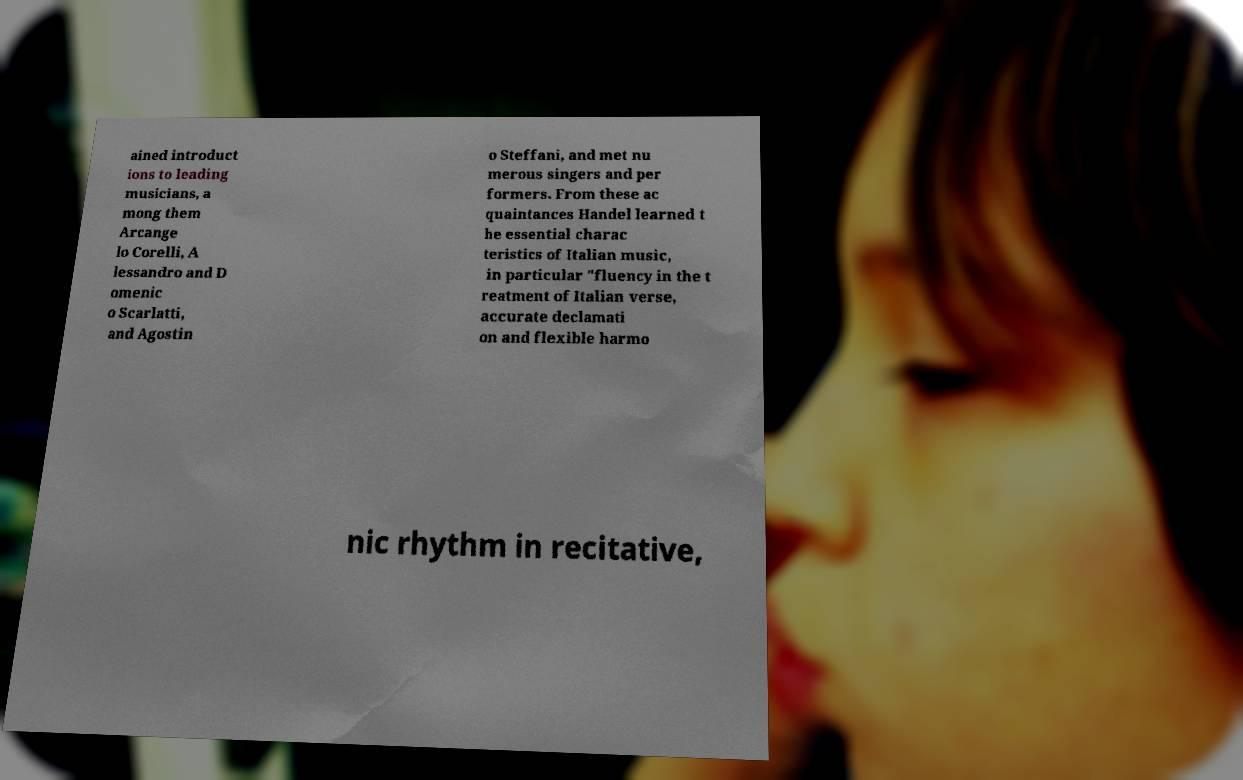There's text embedded in this image that I need extracted. Can you transcribe it verbatim? ained introduct ions to leading musicians, a mong them Arcange lo Corelli, A lessandro and D omenic o Scarlatti, and Agostin o Steffani, and met nu merous singers and per formers. From these ac quaintances Handel learned t he essential charac teristics of Italian music, in particular "fluency in the t reatment of Italian verse, accurate declamati on and flexible harmo nic rhythm in recitative, 